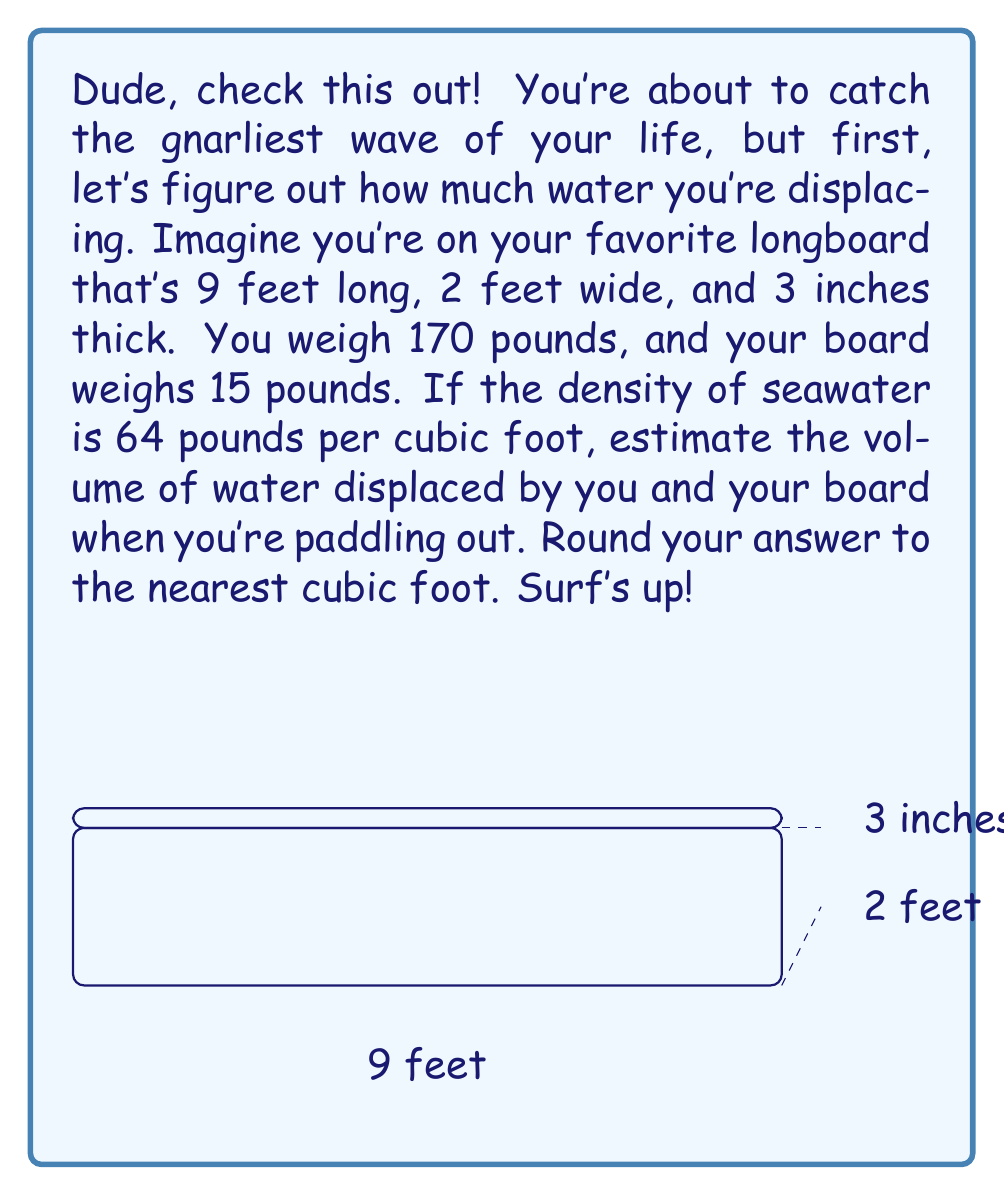Solve this math problem. Alright, let's break this down step-by-step, just like analyzing a perfect wave:

1) First, we need to calculate the total weight that needs to be supported by water:
   Your weight + Board weight = 170 lbs + 15 lbs = 185 lbs

2) Now, let's use Archimedes' principle. The weight of water displaced equals the weight of the object:
   Weight of displaced water = 185 lbs

3) We know the density of seawater is 64 lbs/ft³. To find the volume, we use the formula:
   $$ \text{Volume} = \frac{\text{Weight}}{\text{Density}} $$

4) Plugging in our values:
   $$ \text{Volume} = \frac{185 \text{ lbs}}{64 \text{ lbs/ft}^3} = 2.890625 \text{ ft}^3 $$

5) Rounding to the nearest cubic foot:
   2.890625 ft³ ≈ 3 ft³

So, when you're paddling out, you and your board are displacing approximately 3 cubic feet of water. That's like creating a small barrel wave under your board! Totally tubular!
Answer: 3 ft³ 